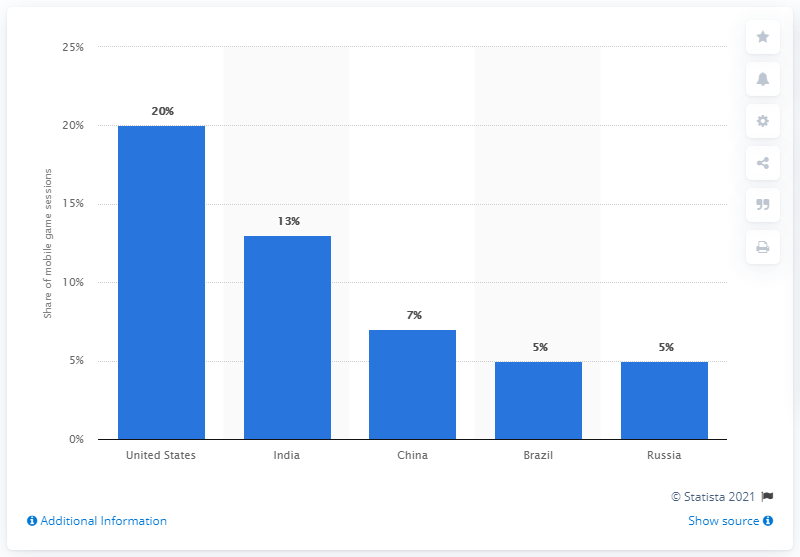Specify some key components in this picture. In 2020, it is estimated that the United States accounted for approximately 38% of global mobile gaming sessions. 